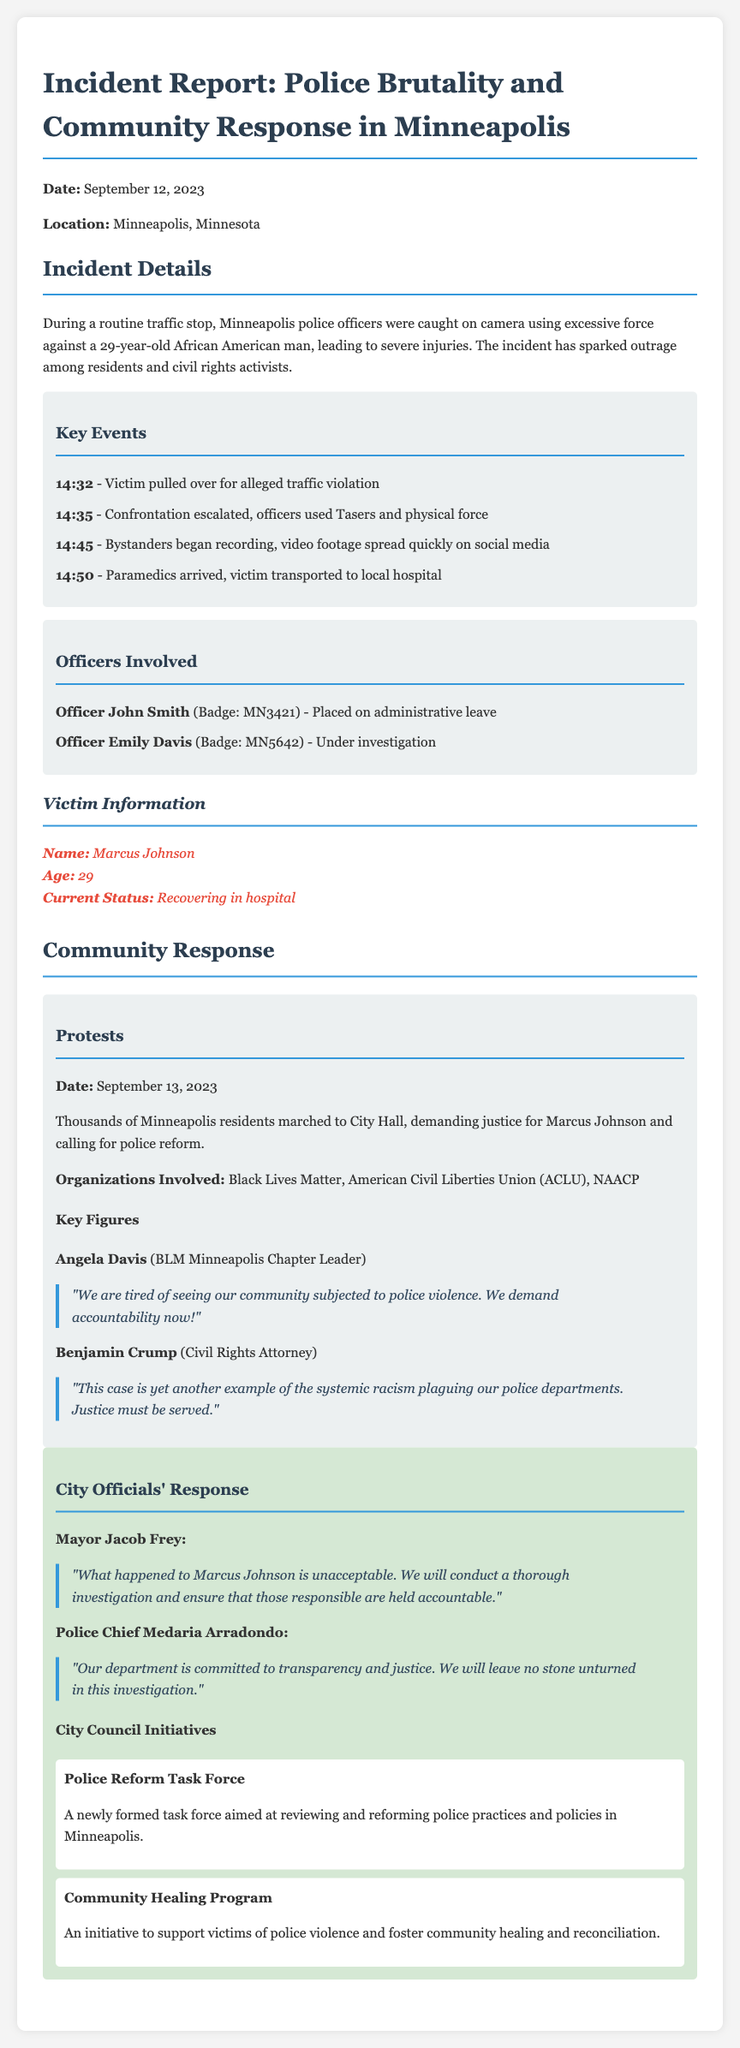What was the date of the incident? The date of the incident reported in the document is September 12, 2023.
Answer: September 12, 2023 Who is the victim? The document identifies the victim of the incident as Marcus Johnson.
Answer: Marcus Johnson What was the age of the victim? The victim's age is mentioned in the document as 29.
Answer: 29 What action did the community take on September 13, 2023? The community marched to City Hall demanding justice, as documented.
Answer: Marched to City Hall Which organizations were involved in the protests? The involved organizations mentioned are Black Lives Matter, ACLU, and NAACP.
Answer: Black Lives Matter, American Civil Liberties Union, NAACP What must the police department ensure according to Police Chief Medaria Arradondo? The police chief emphasizes the department's commitment to transparency and justice.
Answer: Transparency and justice What initiative was formed to review police practices? The newly formed initiative aimed at reviewing police practices is called the Police Reform Task Force.
Answer: Police Reform Task Force Who was placed on administrative leave? Officer John Smith is the officer who was placed on administrative leave.
Answer: Officer John Smith What was the response of Mayor Jacob Frey regarding the incident? Mayor Jacob Frey stated that what happened to Marcus Johnson is unacceptable.
Answer: Unacceptable What time did the paramedics arrive at the scene? The document states that paramedics arrived at 14:50.
Answer: 14:50 